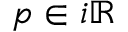<formula> <loc_0><loc_0><loc_500><loc_500>p \in i \mathbb { R }</formula> 